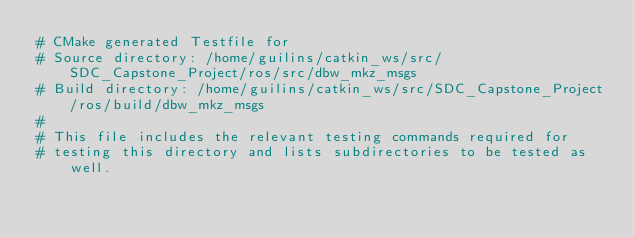Convert code to text. <code><loc_0><loc_0><loc_500><loc_500><_CMake_># CMake generated Testfile for 
# Source directory: /home/guilins/catkin_ws/src/SDC_Capstone_Project/ros/src/dbw_mkz_msgs
# Build directory: /home/guilins/catkin_ws/src/SDC_Capstone_Project/ros/build/dbw_mkz_msgs
# 
# This file includes the relevant testing commands required for 
# testing this directory and lists subdirectories to be tested as well.
</code> 